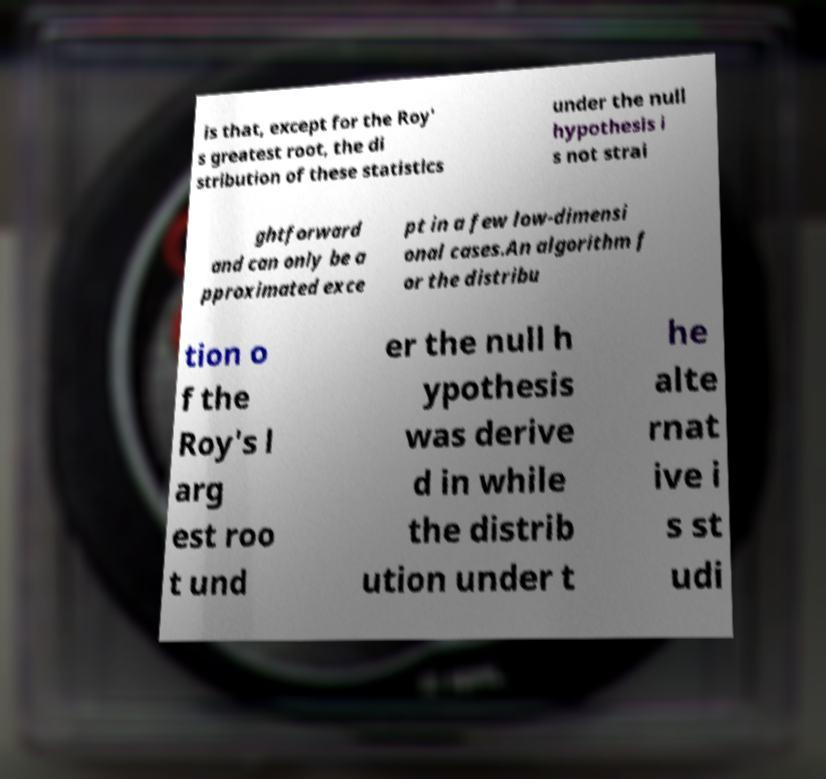I need the written content from this picture converted into text. Can you do that? is that, except for the Roy' s greatest root, the di stribution of these statistics under the null hypothesis i s not strai ghtforward and can only be a pproximated exce pt in a few low-dimensi onal cases.An algorithm f or the distribu tion o f the Roy's l arg est roo t und er the null h ypothesis was derive d in while the distrib ution under t he alte rnat ive i s st udi 